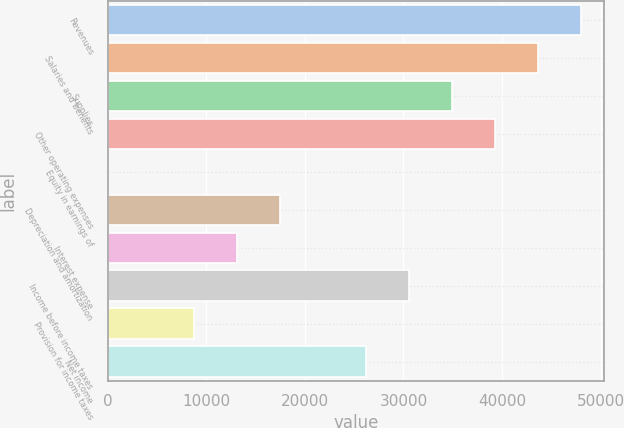Convert chart to OTSL. <chart><loc_0><loc_0><loc_500><loc_500><bar_chart><fcel>Revenues<fcel>Salaries and benefits<fcel>Supplies<fcel>Other operating expenses<fcel>Equity in earnings of<fcel>Depreciation and amortization<fcel>Interest expense<fcel>Income before income taxes<fcel>Provision for income taxes<fcel>Net income<nl><fcel>47970.9<fcel>43614<fcel>34900.2<fcel>39257.1<fcel>45<fcel>17472.6<fcel>13115.7<fcel>30543.3<fcel>8758.8<fcel>26186.4<nl></chart> 